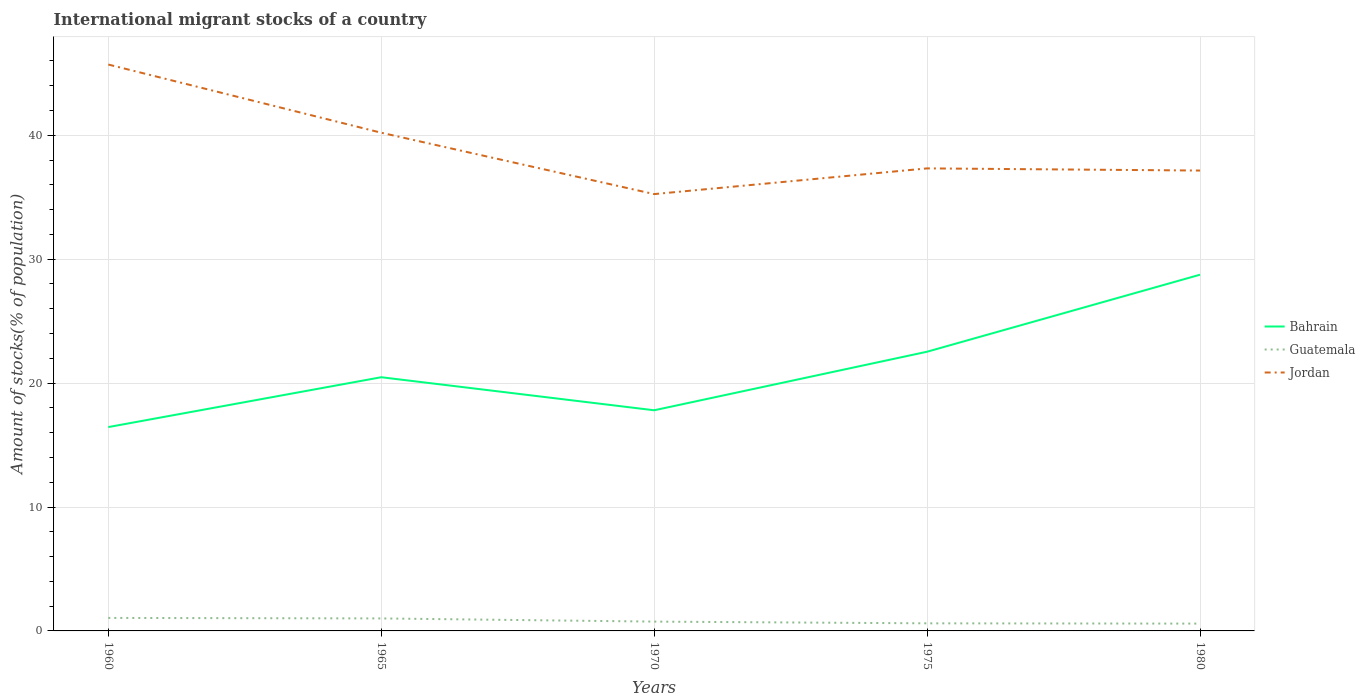Is the number of lines equal to the number of legend labels?
Make the answer very short. Yes. Across all years, what is the maximum amount of stocks in in Bahrain?
Make the answer very short. 16.45. What is the total amount of stocks in in Jordan in the graph?
Keep it short and to the point. 3.05. What is the difference between the highest and the second highest amount of stocks in in Jordan?
Your answer should be compact. 10.46. What is the difference between the highest and the lowest amount of stocks in in Jordan?
Make the answer very short. 2. How many years are there in the graph?
Keep it short and to the point. 5. Are the values on the major ticks of Y-axis written in scientific E-notation?
Give a very brief answer. No. Where does the legend appear in the graph?
Your answer should be compact. Center right. What is the title of the graph?
Offer a terse response. International migrant stocks of a country. Does "Timor-Leste" appear as one of the legend labels in the graph?
Your response must be concise. No. What is the label or title of the Y-axis?
Ensure brevity in your answer.  Amount of stocks(% of population). What is the Amount of stocks(% of population) of Bahrain in 1960?
Give a very brief answer. 16.45. What is the Amount of stocks(% of population) of Guatemala in 1960?
Keep it short and to the point. 1.05. What is the Amount of stocks(% of population) of Jordan in 1960?
Ensure brevity in your answer.  45.71. What is the Amount of stocks(% of population) of Bahrain in 1965?
Keep it short and to the point. 20.47. What is the Amount of stocks(% of population) in Guatemala in 1965?
Give a very brief answer. 1.01. What is the Amount of stocks(% of population) of Jordan in 1965?
Make the answer very short. 40.21. What is the Amount of stocks(% of population) in Bahrain in 1970?
Provide a short and direct response. 17.81. What is the Amount of stocks(% of population) of Guatemala in 1970?
Your response must be concise. 0.75. What is the Amount of stocks(% of population) of Jordan in 1970?
Your answer should be very brief. 35.25. What is the Amount of stocks(% of population) of Bahrain in 1975?
Your answer should be very brief. 22.53. What is the Amount of stocks(% of population) in Guatemala in 1975?
Offer a very short reply. 0.61. What is the Amount of stocks(% of population) of Jordan in 1975?
Give a very brief answer. 37.33. What is the Amount of stocks(% of population) in Bahrain in 1980?
Make the answer very short. 28.75. What is the Amount of stocks(% of population) in Guatemala in 1980?
Make the answer very short. 0.59. What is the Amount of stocks(% of population) of Jordan in 1980?
Offer a very short reply. 37.15. Across all years, what is the maximum Amount of stocks(% of population) of Bahrain?
Provide a short and direct response. 28.75. Across all years, what is the maximum Amount of stocks(% of population) in Guatemala?
Your answer should be compact. 1.05. Across all years, what is the maximum Amount of stocks(% of population) in Jordan?
Ensure brevity in your answer.  45.71. Across all years, what is the minimum Amount of stocks(% of population) in Bahrain?
Ensure brevity in your answer.  16.45. Across all years, what is the minimum Amount of stocks(% of population) in Guatemala?
Keep it short and to the point. 0.59. Across all years, what is the minimum Amount of stocks(% of population) in Jordan?
Your answer should be compact. 35.25. What is the total Amount of stocks(% of population) in Bahrain in the graph?
Your answer should be compact. 106.01. What is the total Amount of stocks(% of population) in Guatemala in the graph?
Ensure brevity in your answer.  4.01. What is the total Amount of stocks(% of population) in Jordan in the graph?
Give a very brief answer. 195.65. What is the difference between the Amount of stocks(% of population) of Bahrain in 1960 and that in 1965?
Give a very brief answer. -4.02. What is the difference between the Amount of stocks(% of population) in Guatemala in 1960 and that in 1965?
Provide a succinct answer. 0.04. What is the difference between the Amount of stocks(% of population) in Jordan in 1960 and that in 1965?
Offer a terse response. 5.5. What is the difference between the Amount of stocks(% of population) in Bahrain in 1960 and that in 1970?
Offer a terse response. -1.36. What is the difference between the Amount of stocks(% of population) of Guatemala in 1960 and that in 1970?
Keep it short and to the point. 0.3. What is the difference between the Amount of stocks(% of population) of Jordan in 1960 and that in 1970?
Offer a terse response. 10.46. What is the difference between the Amount of stocks(% of population) in Bahrain in 1960 and that in 1975?
Ensure brevity in your answer.  -6.08. What is the difference between the Amount of stocks(% of population) of Guatemala in 1960 and that in 1975?
Keep it short and to the point. 0.44. What is the difference between the Amount of stocks(% of population) in Jordan in 1960 and that in 1975?
Keep it short and to the point. 8.38. What is the difference between the Amount of stocks(% of population) of Bahrain in 1960 and that in 1980?
Offer a very short reply. -12.3. What is the difference between the Amount of stocks(% of population) of Guatemala in 1960 and that in 1980?
Your response must be concise. 0.46. What is the difference between the Amount of stocks(% of population) of Jordan in 1960 and that in 1980?
Give a very brief answer. 8.56. What is the difference between the Amount of stocks(% of population) of Bahrain in 1965 and that in 1970?
Give a very brief answer. 2.67. What is the difference between the Amount of stocks(% of population) in Guatemala in 1965 and that in 1970?
Provide a succinct answer. 0.26. What is the difference between the Amount of stocks(% of population) of Jordan in 1965 and that in 1970?
Provide a succinct answer. 4.95. What is the difference between the Amount of stocks(% of population) in Bahrain in 1965 and that in 1975?
Your answer should be compact. -2.06. What is the difference between the Amount of stocks(% of population) of Guatemala in 1965 and that in 1975?
Offer a very short reply. 0.4. What is the difference between the Amount of stocks(% of population) in Jordan in 1965 and that in 1975?
Give a very brief answer. 2.88. What is the difference between the Amount of stocks(% of population) of Bahrain in 1965 and that in 1980?
Give a very brief answer. -8.27. What is the difference between the Amount of stocks(% of population) in Guatemala in 1965 and that in 1980?
Keep it short and to the point. 0.42. What is the difference between the Amount of stocks(% of population) of Jordan in 1965 and that in 1980?
Make the answer very short. 3.05. What is the difference between the Amount of stocks(% of population) in Bahrain in 1970 and that in 1975?
Ensure brevity in your answer.  -4.73. What is the difference between the Amount of stocks(% of population) of Guatemala in 1970 and that in 1975?
Provide a short and direct response. 0.14. What is the difference between the Amount of stocks(% of population) in Jordan in 1970 and that in 1975?
Your answer should be very brief. -2.07. What is the difference between the Amount of stocks(% of population) in Bahrain in 1970 and that in 1980?
Give a very brief answer. -10.94. What is the difference between the Amount of stocks(% of population) in Guatemala in 1970 and that in 1980?
Keep it short and to the point. 0.16. What is the difference between the Amount of stocks(% of population) in Jordan in 1970 and that in 1980?
Your answer should be compact. -1.9. What is the difference between the Amount of stocks(% of population) of Bahrain in 1975 and that in 1980?
Your response must be concise. -6.22. What is the difference between the Amount of stocks(% of population) in Guatemala in 1975 and that in 1980?
Make the answer very short. 0.02. What is the difference between the Amount of stocks(% of population) of Jordan in 1975 and that in 1980?
Give a very brief answer. 0.17. What is the difference between the Amount of stocks(% of population) of Bahrain in 1960 and the Amount of stocks(% of population) of Guatemala in 1965?
Offer a terse response. 15.44. What is the difference between the Amount of stocks(% of population) in Bahrain in 1960 and the Amount of stocks(% of population) in Jordan in 1965?
Your answer should be very brief. -23.75. What is the difference between the Amount of stocks(% of population) in Guatemala in 1960 and the Amount of stocks(% of population) in Jordan in 1965?
Keep it short and to the point. -39.16. What is the difference between the Amount of stocks(% of population) in Bahrain in 1960 and the Amount of stocks(% of population) in Guatemala in 1970?
Offer a very short reply. 15.7. What is the difference between the Amount of stocks(% of population) of Bahrain in 1960 and the Amount of stocks(% of population) of Jordan in 1970?
Your answer should be compact. -18.8. What is the difference between the Amount of stocks(% of population) of Guatemala in 1960 and the Amount of stocks(% of population) of Jordan in 1970?
Your answer should be very brief. -34.2. What is the difference between the Amount of stocks(% of population) of Bahrain in 1960 and the Amount of stocks(% of population) of Guatemala in 1975?
Your answer should be very brief. 15.84. What is the difference between the Amount of stocks(% of population) in Bahrain in 1960 and the Amount of stocks(% of population) in Jordan in 1975?
Provide a succinct answer. -20.88. What is the difference between the Amount of stocks(% of population) in Guatemala in 1960 and the Amount of stocks(% of population) in Jordan in 1975?
Make the answer very short. -36.28. What is the difference between the Amount of stocks(% of population) in Bahrain in 1960 and the Amount of stocks(% of population) in Guatemala in 1980?
Your response must be concise. 15.86. What is the difference between the Amount of stocks(% of population) in Bahrain in 1960 and the Amount of stocks(% of population) in Jordan in 1980?
Offer a terse response. -20.7. What is the difference between the Amount of stocks(% of population) in Guatemala in 1960 and the Amount of stocks(% of population) in Jordan in 1980?
Give a very brief answer. -36.1. What is the difference between the Amount of stocks(% of population) in Bahrain in 1965 and the Amount of stocks(% of population) in Guatemala in 1970?
Your answer should be compact. 19.72. What is the difference between the Amount of stocks(% of population) of Bahrain in 1965 and the Amount of stocks(% of population) of Jordan in 1970?
Offer a very short reply. -14.78. What is the difference between the Amount of stocks(% of population) in Guatemala in 1965 and the Amount of stocks(% of population) in Jordan in 1970?
Provide a short and direct response. -34.24. What is the difference between the Amount of stocks(% of population) of Bahrain in 1965 and the Amount of stocks(% of population) of Guatemala in 1975?
Provide a short and direct response. 19.86. What is the difference between the Amount of stocks(% of population) in Bahrain in 1965 and the Amount of stocks(% of population) in Jordan in 1975?
Provide a short and direct response. -16.85. What is the difference between the Amount of stocks(% of population) of Guatemala in 1965 and the Amount of stocks(% of population) of Jordan in 1975?
Your answer should be compact. -36.32. What is the difference between the Amount of stocks(% of population) of Bahrain in 1965 and the Amount of stocks(% of population) of Guatemala in 1980?
Provide a short and direct response. 19.88. What is the difference between the Amount of stocks(% of population) in Bahrain in 1965 and the Amount of stocks(% of population) in Jordan in 1980?
Offer a terse response. -16.68. What is the difference between the Amount of stocks(% of population) of Guatemala in 1965 and the Amount of stocks(% of population) of Jordan in 1980?
Provide a short and direct response. -36.15. What is the difference between the Amount of stocks(% of population) in Bahrain in 1970 and the Amount of stocks(% of population) in Guatemala in 1975?
Your answer should be very brief. 17.19. What is the difference between the Amount of stocks(% of population) in Bahrain in 1970 and the Amount of stocks(% of population) in Jordan in 1975?
Your answer should be compact. -19.52. What is the difference between the Amount of stocks(% of population) of Guatemala in 1970 and the Amount of stocks(% of population) of Jordan in 1975?
Keep it short and to the point. -36.58. What is the difference between the Amount of stocks(% of population) in Bahrain in 1970 and the Amount of stocks(% of population) in Guatemala in 1980?
Give a very brief answer. 17.22. What is the difference between the Amount of stocks(% of population) of Bahrain in 1970 and the Amount of stocks(% of population) of Jordan in 1980?
Your answer should be compact. -19.35. What is the difference between the Amount of stocks(% of population) of Guatemala in 1970 and the Amount of stocks(% of population) of Jordan in 1980?
Give a very brief answer. -36.4. What is the difference between the Amount of stocks(% of population) of Bahrain in 1975 and the Amount of stocks(% of population) of Guatemala in 1980?
Provide a succinct answer. 21.94. What is the difference between the Amount of stocks(% of population) in Bahrain in 1975 and the Amount of stocks(% of population) in Jordan in 1980?
Your answer should be compact. -14.62. What is the difference between the Amount of stocks(% of population) of Guatemala in 1975 and the Amount of stocks(% of population) of Jordan in 1980?
Your answer should be compact. -36.54. What is the average Amount of stocks(% of population) of Bahrain per year?
Your response must be concise. 21.2. What is the average Amount of stocks(% of population) of Guatemala per year?
Your response must be concise. 0.8. What is the average Amount of stocks(% of population) of Jordan per year?
Offer a terse response. 39.13. In the year 1960, what is the difference between the Amount of stocks(% of population) in Bahrain and Amount of stocks(% of population) in Guatemala?
Give a very brief answer. 15.4. In the year 1960, what is the difference between the Amount of stocks(% of population) of Bahrain and Amount of stocks(% of population) of Jordan?
Offer a terse response. -29.26. In the year 1960, what is the difference between the Amount of stocks(% of population) in Guatemala and Amount of stocks(% of population) in Jordan?
Your response must be concise. -44.66. In the year 1965, what is the difference between the Amount of stocks(% of population) in Bahrain and Amount of stocks(% of population) in Guatemala?
Keep it short and to the point. 19.47. In the year 1965, what is the difference between the Amount of stocks(% of population) in Bahrain and Amount of stocks(% of population) in Jordan?
Offer a terse response. -19.73. In the year 1965, what is the difference between the Amount of stocks(% of population) in Guatemala and Amount of stocks(% of population) in Jordan?
Make the answer very short. -39.2. In the year 1970, what is the difference between the Amount of stocks(% of population) in Bahrain and Amount of stocks(% of population) in Guatemala?
Your answer should be very brief. 17.05. In the year 1970, what is the difference between the Amount of stocks(% of population) in Bahrain and Amount of stocks(% of population) in Jordan?
Give a very brief answer. -17.45. In the year 1970, what is the difference between the Amount of stocks(% of population) in Guatemala and Amount of stocks(% of population) in Jordan?
Ensure brevity in your answer.  -34.5. In the year 1975, what is the difference between the Amount of stocks(% of population) of Bahrain and Amount of stocks(% of population) of Guatemala?
Offer a very short reply. 21.92. In the year 1975, what is the difference between the Amount of stocks(% of population) in Bahrain and Amount of stocks(% of population) in Jordan?
Offer a very short reply. -14.8. In the year 1975, what is the difference between the Amount of stocks(% of population) in Guatemala and Amount of stocks(% of population) in Jordan?
Ensure brevity in your answer.  -36.72. In the year 1980, what is the difference between the Amount of stocks(% of population) of Bahrain and Amount of stocks(% of population) of Guatemala?
Ensure brevity in your answer.  28.16. In the year 1980, what is the difference between the Amount of stocks(% of population) of Bahrain and Amount of stocks(% of population) of Jordan?
Provide a succinct answer. -8.41. In the year 1980, what is the difference between the Amount of stocks(% of population) of Guatemala and Amount of stocks(% of population) of Jordan?
Make the answer very short. -36.56. What is the ratio of the Amount of stocks(% of population) of Bahrain in 1960 to that in 1965?
Your answer should be compact. 0.8. What is the ratio of the Amount of stocks(% of population) in Guatemala in 1960 to that in 1965?
Give a very brief answer. 1.04. What is the ratio of the Amount of stocks(% of population) of Jordan in 1960 to that in 1965?
Your answer should be compact. 1.14. What is the ratio of the Amount of stocks(% of population) of Bahrain in 1960 to that in 1970?
Your answer should be very brief. 0.92. What is the ratio of the Amount of stocks(% of population) of Guatemala in 1960 to that in 1970?
Your response must be concise. 1.4. What is the ratio of the Amount of stocks(% of population) in Jordan in 1960 to that in 1970?
Provide a short and direct response. 1.3. What is the ratio of the Amount of stocks(% of population) of Bahrain in 1960 to that in 1975?
Your response must be concise. 0.73. What is the ratio of the Amount of stocks(% of population) in Guatemala in 1960 to that in 1975?
Ensure brevity in your answer.  1.71. What is the ratio of the Amount of stocks(% of population) in Jordan in 1960 to that in 1975?
Give a very brief answer. 1.22. What is the ratio of the Amount of stocks(% of population) of Bahrain in 1960 to that in 1980?
Ensure brevity in your answer.  0.57. What is the ratio of the Amount of stocks(% of population) of Guatemala in 1960 to that in 1980?
Provide a succinct answer. 1.78. What is the ratio of the Amount of stocks(% of population) in Jordan in 1960 to that in 1980?
Offer a very short reply. 1.23. What is the ratio of the Amount of stocks(% of population) in Bahrain in 1965 to that in 1970?
Give a very brief answer. 1.15. What is the ratio of the Amount of stocks(% of population) of Guatemala in 1965 to that in 1970?
Provide a succinct answer. 1.34. What is the ratio of the Amount of stocks(% of population) in Jordan in 1965 to that in 1970?
Give a very brief answer. 1.14. What is the ratio of the Amount of stocks(% of population) of Bahrain in 1965 to that in 1975?
Provide a short and direct response. 0.91. What is the ratio of the Amount of stocks(% of population) in Guatemala in 1965 to that in 1975?
Offer a terse response. 1.65. What is the ratio of the Amount of stocks(% of population) of Jordan in 1965 to that in 1975?
Your response must be concise. 1.08. What is the ratio of the Amount of stocks(% of population) of Bahrain in 1965 to that in 1980?
Give a very brief answer. 0.71. What is the ratio of the Amount of stocks(% of population) in Guatemala in 1965 to that in 1980?
Provide a short and direct response. 1.71. What is the ratio of the Amount of stocks(% of population) in Jordan in 1965 to that in 1980?
Give a very brief answer. 1.08. What is the ratio of the Amount of stocks(% of population) in Bahrain in 1970 to that in 1975?
Provide a succinct answer. 0.79. What is the ratio of the Amount of stocks(% of population) in Guatemala in 1970 to that in 1975?
Offer a very short reply. 1.23. What is the ratio of the Amount of stocks(% of population) of Jordan in 1970 to that in 1975?
Your response must be concise. 0.94. What is the ratio of the Amount of stocks(% of population) of Bahrain in 1970 to that in 1980?
Provide a short and direct response. 0.62. What is the ratio of the Amount of stocks(% of population) of Guatemala in 1970 to that in 1980?
Keep it short and to the point. 1.27. What is the ratio of the Amount of stocks(% of population) in Jordan in 1970 to that in 1980?
Your response must be concise. 0.95. What is the ratio of the Amount of stocks(% of population) of Bahrain in 1975 to that in 1980?
Make the answer very short. 0.78. What is the ratio of the Amount of stocks(% of population) of Guatemala in 1975 to that in 1980?
Offer a very short reply. 1.04. What is the difference between the highest and the second highest Amount of stocks(% of population) in Bahrain?
Give a very brief answer. 6.22. What is the difference between the highest and the second highest Amount of stocks(% of population) of Guatemala?
Provide a short and direct response. 0.04. What is the difference between the highest and the second highest Amount of stocks(% of population) of Jordan?
Offer a terse response. 5.5. What is the difference between the highest and the lowest Amount of stocks(% of population) of Bahrain?
Your answer should be very brief. 12.3. What is the difference between the highest and the lowest Amount of stocks(% of population) of Guatemala?
Ensure brevity in your answer.  0.46. What is the difference between the highest and the lowest Amount of stocks(% of population) in Jordan?
Provide a short and direct response. 10.46. 